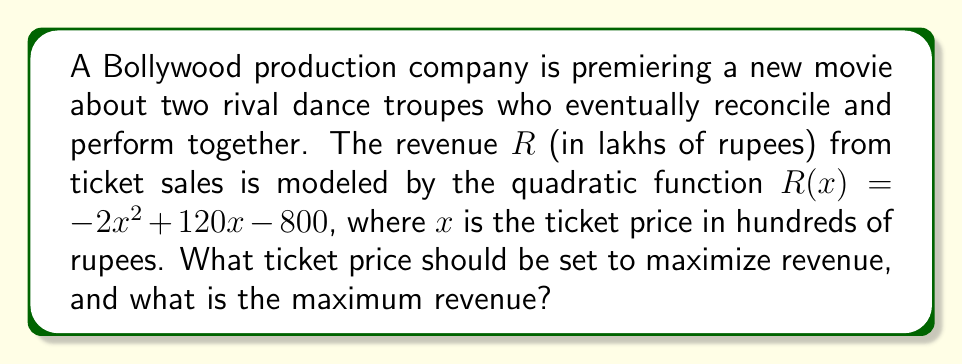Show me your answer to this math problem. To solve this problem, we'll follow these steps:

1) The revenue function is a quadratic function in the form $R(x) = -2x^2 + 120x - 800$.

2) To find the maximum revenue, we need to find the vertex of this parabola. The x-coordinate of the vertex will give us the optimal ticket price, and the y-coordinate will give us the maximum revenue.

3) For a quadratic function in the form $f(x) = ax^2 + bx + c$, the x-coordinate of the vertex is given by $x = -\frac{b}{2a}$.

4) In our case, $a = -2$, $b = 120$, so:

   $x = -\frac{120}{2(-2)} = -\frac{120}{-4} = 30$

5) This means the optimal ticket price is 30 hundred rupees, or 3000 rupees.

6) To find the maximum revenue, we substitute this x-value back into our original function:

   $R(30) = -2(30)^2 + 120(30) - 800$
          $= -2(900) + 3600 - 800$
          $= -1800 + 3600 - 800$
          $= 1000$

7) Therefore, the maximum revenue is 1000 lakhs of rupees, or 100,000,000 rupees.
Answer: Optimal ticket price: 3000 rupees; Maximum revenue: 100,000,000 rupees 